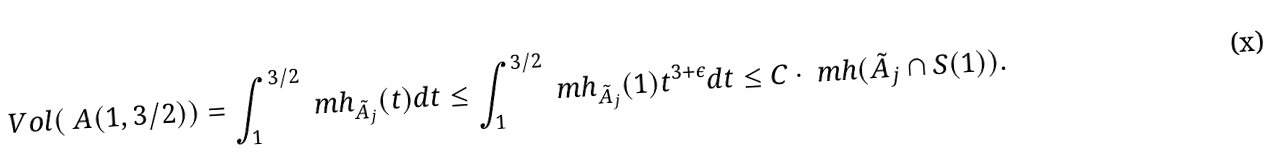<formula> <loc_0><loc_0><loc_500><loc_500>V o l ( \ A ( 1 , 3 / 2 ) ) = \int _ { 1 } ^ { 3 / 2 } \ m h _ { \tilde { A } _ { j } } ( t ) d t & \leq \int _ { 1 } ^ { 3 / 2 } \ m h _ { \tilde { A } _ { j } } ( 1 ) t ^ { 3 + \epsilon } d t \leq C \cdot \ m h ( \tilde { A } _ { j } \cap S ( 1 ) ) .</formula> 